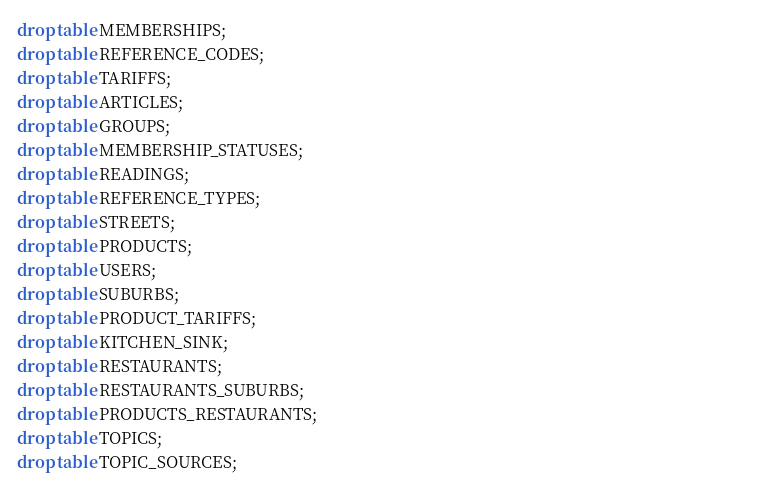Convert code to text. <code><loc_0><loc_0><loc_500><loc_500><_SQL_>drop table MEMBERSHIPS;                                                                                                                    
drop table REFERENCE_CODES;                                                                                                                 
drop table TARIFFS;                                                                                                                         
drop table ARTICLES;                                                                                                                        
drop table GROUPS;                                                                                                                          
drop table MEMBERSHIP_STATUSES;                                                                                                             
drop table READINGS;                                                                                                                        
drop table REFERENCE_TYPES;                                                                                                                 
drop table STREETS;                                                                                                                         
drop table PRODUCTS;                                                                                                                        
drop table USERS;                                                                                                                           
drop table SUBURBS;                                                                                                                         
drop table PRODUCT_TARIFFS; 
drop table KITCHEN_SINK;
drop table RESTAURANTS;
drop table RESTAURANTS_SUBURBS;
drop table PRODUCTS_RESTAURANTS;
drop table TOPICS;
drop table TOPIC_SOURCES;</code> 